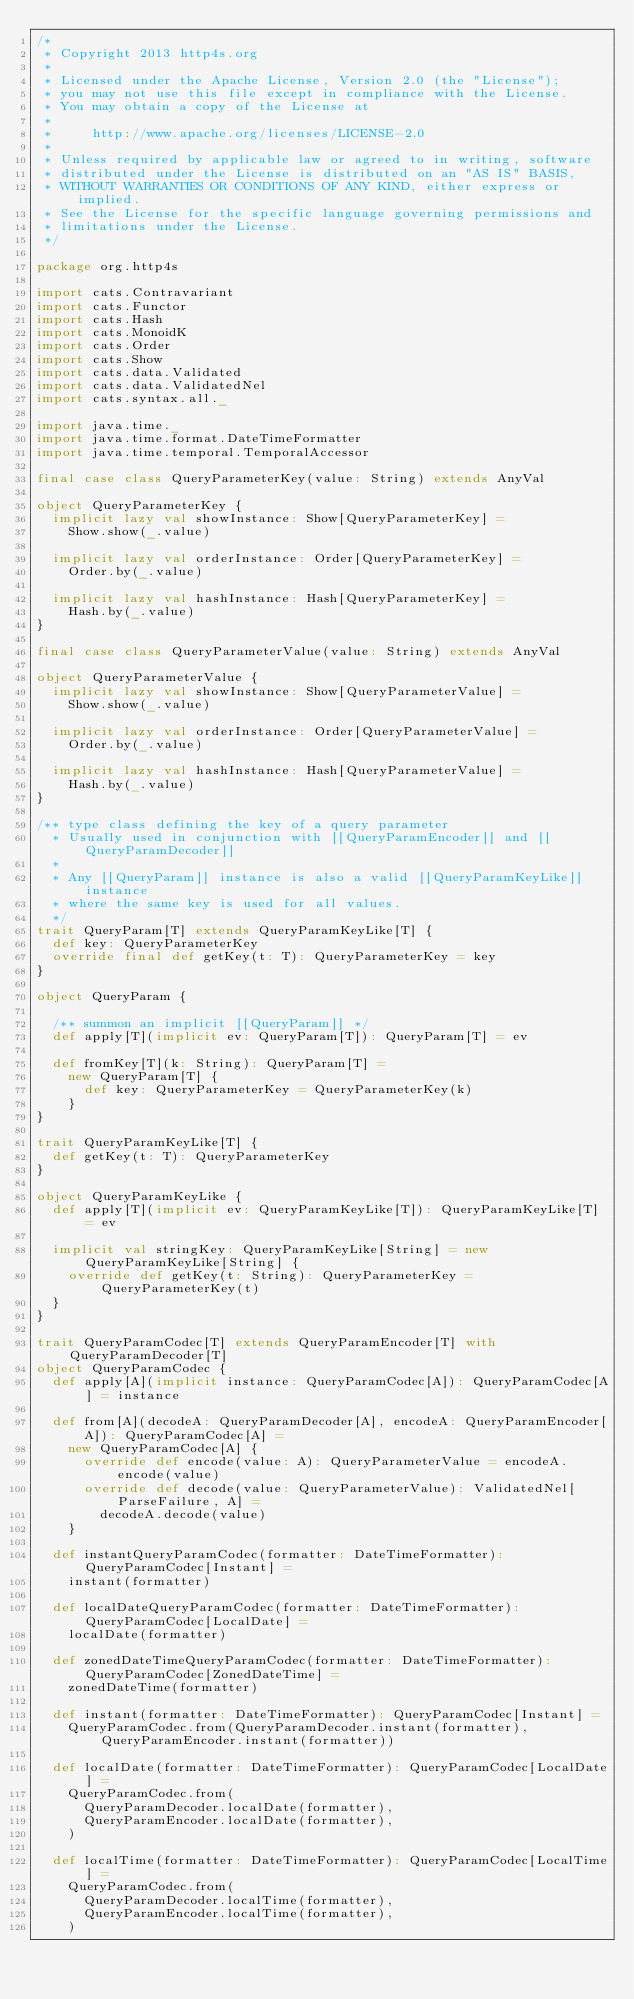<code> <loc_0><loc_0><loc_500><loc_500><_Scala_>/*
 * Copyright 2013 http4s.org
 *
 * Licensed under the Apache License, Version 2.0 (the "License");
 * you may not use this file except in compliance with the License.
 * You may obtain a copy of the License at
 *
 *     http://www.apache.org/licenses/LICENSE-2.0
 *
 * Unless required by applicable law or agreed to in writing, software
 * distributed under the License is distributed on an "AS IS" BASIS,
 * WITHOUT WARRANTIES OR CONDITIONS OF ANY KIND, either express or implied.
 * See the License for the specific language governing permissions and
 * limitations under the License.
 */

package org.http4s

import cats.Contravariant
import cats.Functor
import cats.Hash
import cats.MonoidK
import cats.Order
import cats.Show
import cats.data.Validated
import cats.data.ValidatedNel
import cats.syntax.all._

import java.time._
import java.time.format.DateTimeFormatter
import java.time.temporal.TemporalAccessor

final case class QueryParameterKey(value: String) extends AnyVal

object QueryParameterKey {
  implicit lazy val showInstance: Show[QueryParameterKey] =
    Show.show(_.value)

  implicit lazy val orderInstance: Order[QueryParameterKey] =
    Order.by(_.value)

  implicit lazy val hashInstance: Hash[QueryParameterKey] =
    Hash.by(_.value)
}

final case class QueryParameterValue(value: String) extends AnyVal

object QueryParameterValue {
  implicit lazy val showInstance: Show[QueryParameterValue] =
    Show.show(_.value)

  implicit lazy val orderInstance: Order[QueryParameterValue] =
    Order.by(_.value)

  implicit lazy val hashInstance: Hash[QueryParameterValue] =
    Hash.by(_.value)
}

/** type class defining the key of a query parameter
  * Usually used in conjunction with [[QueryParamEncoder]] and [[QueryParamDecoder]]
  *
  * Any [[QueryParam]] instance is also a valid [[QueryParamKeyLike]] instance
  * where the same key is used for all values.
  */
trait QueryParam[T] extends QueryParamKeyLike[T] {
  def key: QueryParameterKey
  override final def getKey(t: T): QueryParameterKey = key
}

object QueryParam {

  /** summon an implicit [[QueryParam]] */
  def apply[T](implicit ev: QueryParam[T]): QueryParam[T] = ev

  def fromKey[T](k: String): QueryParam[T] =
    new QueryParam[T] {
      def key: QueryParameterKey = QueryParameterKey(k)
    }
}

trait QueryParamKeyLike[T] {
  def getKey(t: T): QueryParameterKey
}

object QueryParamKeyLike {
  def apply[T](implicit ev: QueryParamKeyLike[T]): QueryParamKeyLike[T] = ev

  implicit val stringKey: QueryParamKeyLike[String] = new QueryParamKeyLike[String] {
    override def getKey(t: String): QueryParameterKey = QueryParameterKey(t)
  }
}

trait QueryParamCodec[T] extends QueryParamEncoder[T] with QueryParamDecoder[T]
object QueryParamCodec {
  def apply[A](implicit instance: QueryParamCodec[A]): QueryParamCodec[A] = instance

  def from[A](decodeA: QueryParamDecoder[A], encodeA: QueryParamEncoder[A]): QueryParamCodec[A] =
    new QueryParamCodec[A] {
      override def encode(value: A): QueryParameterValue = encodeA.encode(value)
      override def decode(value: QueryParameterValue): ValidatedNel[ParseFailure, A] =
        decodeA.decode(value)
    }

  def instantQueryParamCodec(formatter: DateTimeFormatter): QueryParamCodec[Instant] =
    instant(formatter)

  def localDateQueryParamCodec(formatter: DateTimeFormatter): QueryParamCodec[LocalDate] =
    localDate(formatter)

  def zonedDateTimeQueryParamCodec(formatter: DateTimeFormatter): QueryParamCodec[ZonedDateTime] =
    zonedDateTime(formatter)

  def instant(formatter: DateTimeFormatter): QueryParamCodec[Instant] =
    QueryParamCodec.from(QueryParamDecoder.instant(formatter), QueryParamEncoder.instant(formatter))

  def localDate(formatter: DateTimeFormatter): QueryParamCodec[LocalDate] =
    QueryParamCodec.from(
      QueryParamDecoder.localDate(formatter),
      QueryParamEncoder.localDate(formatter),
    )

  def localTime(formatter: DateTimeFormatter): QueryParamCodec[LocalTime] =
    QueryParamCodec.from(
      QueryParamDecoder.localTime(formatter),
      QueryParamEncoder.localTime(formatter),
    )
</code> 